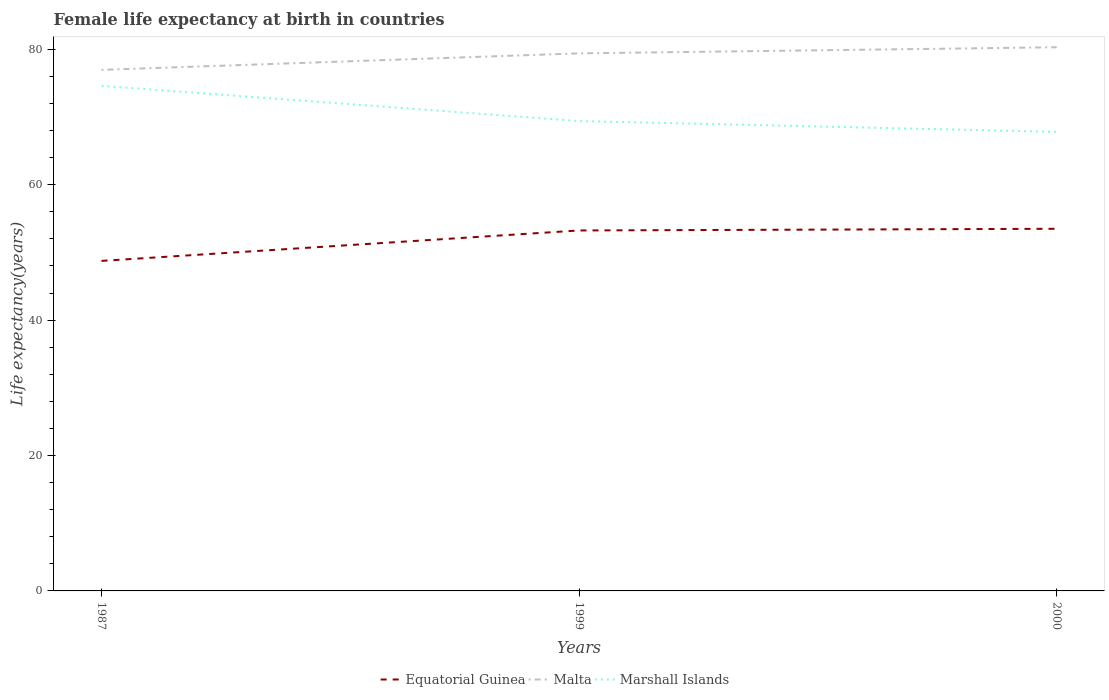Does the line corresponding to Malta intersect with the line corresponding to Marshall Islands?
Give a very brief answer. No. Is the number of lines equal to the number of legend labels?
Keep it short and to the point. Yes. Across all years, what is the maximum female life expectancy at birth in Equatorial Guinea?
Your answer should be compact. 48.74. What is the total female life expectancy at birth in Malta in the graph?
Make the answer very short. -0.9. What is the difference between the highest and the second highest female life expectancy at birth in Marshall Islands?
Your response must be concise. 6.8. What is the difference between the highest and the lowest female life expectancy at birth in Equatorial Guinea?
Make the answer very short. 2. How many lines are there?
Your answer should be compact. 3. How many years are there in the graph?
Your response must be concise. 3. Does the graph contain any zero values?
Your answer should be very brief. No. Does the graph contain grids?
Keep it short and to the point. No. Where does the legend appear in the graph?
Your answer should be compact. Bottom center. How are the legend labels stacked?
Offer a very short reply. Horizontal. What is the title of the graph?
Provide a short and direct response. Female life expectancy at birth in countries. What is the label or title of the Y-axis?
Make the answer very short. Life expectancy(years). What is the Life expectancy(years) in Equatorial Guinea in 1987?
Your answer should be compact. 48.74. What is the Life expectancy(years) in Malta in 1987?
Your answer should be very brief. 76.96. What is the Life expectancy(years) of Marshall Islands in 1987?
Offer a very short reply. 74.6. What is the Life expectancy(years) of Equatorial Guinea in 1999?
Ensure brevity in your answer.  53.24. What is the Life expectancy(years) of Malta in 1999?
Give a very brief answer. 79.4. What is the Life expectancy(years) in Marshall Islands in 1999?
Your answer should be compact. 69.4. What is the Life expectancy(years) in Equatorial Guinea in 2000?
Offer a very short reply. 53.49. What is the Life expectancy(years) of Malta in 2000?
Keep it short and to the point. 80.3. What is the Life expectancy(years) of Marshall Islands in 2000?
Provide a short and direct response. 67.8. Across all years, what is the maximum Life expectancy(years) of Equatorial Guinea?
Offer a terse response. 53.49. Across all years, what is the maximum Life expectancy(years) of Malta?
Your response must be concise. 80.3. Across all years, what is the maximum Life expectancy(years) of Marshall Islands?
Ensure brevity in your answer.  74.6. Across all years, what is the minimum Life expectancy(years) of Equatorial Guinea?
Your response must be concise. 48.74. Across all years, what is the minimum Life expectancy(years) of Malta?
Provide a succinct answer. 76.96. Across all years, what is the minimum Life expectancy(years) in Marshall Islands?
Keep it short and to the point. 67.8. What is the total Life expectancy(years) in Equatorial Guinea in the graph?
Make the answer very short. 155.47. What is the total Life expectancy(years) of Malta in the graph?
Make the answer very short. 236.66. What is the total Life expectancy(years) in Marshall Islands in the graph?
Offer a very short reply. 211.8. What is the difference between the Life expectancy(years) in Equatorial Guinea in 1987 and that in 1999?
Give a very brief answer. -4.5. What is the difference between the Life expectancy(years) in Malta in 1987 and that in 1999?
Your answer should be very brief. -2.44. What is the difference between the Life expectancy(years) in Marshall Islands in 1987 and that in 1999?
Provide a short and direct response. 5.2. What is the difference between the Life expectancy(years) of Equatorial Guinea in 1987 and that in 2000?
Your answer should be compact. -4.74. What is the difference between the Life expectancy(years) of Malta in 1987 and that in 2000?
Offer a terse response. -3.34. What is the difference between the Life expectancy(years) of Equatorial Guinea in 1999 and that in 2000?
Provide a succinct answer. -0.25. What is the difference between the Life expectancy(years) in Marshall Islands in 1999 and that in 2000?
Make the answer very short. 1.6. What is the difference between the Life expectancy(years) of Equatorial Guinea in 1987 and the Life expectancy(years) of Malta in 1999?
Offer a terse response. -30.66. What is the difference between the Life expectancy(years) of Equatorial Guinea in 1987 and the Life expectancy(years) of Marshall Islands in 1999?
Ensure brevity in your answer.  -20.66. What is the difference between the Life expectancy(years) in Malta in 1987 and the Life expectancy(years) in Marshall Islands in 1999?
Keep it short and to the point. 7.56. What is the difference between the Life expectancy(years) of Equatorial Guinea in 1987 and the Life expectancy(years) of Malta in 2000?
Keep it short and to the point. -31.55. What is the difference between the Life expectancy(years) in Equatorial Guinea in 1987 and the Life expectancy(years) in Marshall Islands in 2000?
Keep it short and to the point. -19.05. What is the difference between the Life expectancy(years) in Malta in 1987 and the Life expectancy(years) in Marshall Islands in 2000?
Ensure brevity in your answer.  9.16. What is the difference between the Life expectancy(years) of Equatorial Guinea in 1999 and the Life expectancy(years) of Malta in 2000?
Offer a terse response. -27.06. What is the difference between the Life expectancy(years) of Equatorial Guinea in 1999 and the Life expectancy(years) of Marshall Islands in 2000?
Your answer should be very brief. -14.56. What is the average Life expectancy(years) in Equatorial Guinea per year?
Your answer should be very brief. 51.83. What is the average Life expectancy(years) of Malta per year?
Provide a short and direct response. 78.89. What is the average Life expectancy(years) of Marshall Islands per year?
Provide a short and direct response. 70.6. In the year 1987, what is the difference between the Life expectancy(years) in Equatorial Guinea and Life expectancy(years) in Malta?
Offer a very short reply. -28.22. In the year 1987, what is the difference between the Life expectancy(years) of Equatorial Guinea and Life expectancy(years) of Marshall Islands?
Keep it short and to the point. -25.86. In the year 1987, what is the difference between the Life expectancy(years) of Malta and Life expectancy(years) of Marshall Islands?
Provide a short and direct response. 2.36. In the year 1999, what is the difference between the Life expectancy(years) in Equatorial Guinea and Life expectancy(years) in Malta?
Offer a terse response. -26.16. In the year 1999, what is the difference between the Life expectancy(years) in Equatorial Guinea and Life expectancy(years) in Marshall Islands?
Your response must be concise. -16.16. In the year 1999, what is the difference between the Life expectancy(years) of Malta and Life expectancy(years) of Marshall Islands?
Provide a succinct answer. 10. In the year 2000, what is the difference between the Life expectancy(years) in Equatorial Guinea and Life expectancy(years) in Malta?
Your response must be concise. -26.81. In the year 2000, what is the difference between the Life expectancy(years) of Equatorial Guinea and Life expectancy(years) of Marshall Islands?
Ensure brevity in your answer.  -14.31. What is the ratio of the Life expectancy(years) of Equatorial Guinea in 1987 to that in 1999?
Provide a succinct answer. 0.92. What is the ratio of the Life expectancy(years) of Malta in 1987 to that in 1999?
Your response must be concise. 0.97. What is the ratio of the Life expectancy(years) of Marshall Islands in 1987 to that in 1999?
Give a very brief answer. 1.07. What is the ratio of the Life expectancy(years) in Equatorial Guinea in 1987 to that in 2000?
Provide a succinct answer. 0.91. What is the ratio of the Life expectancy(years) of Malta in 1987 to that in 2000?
Give a very brief answer. 0.96. What is the ratio of the Life expectancy(years) of Marshall Islands in 1987 to that in 2000?
Your answer should be compact. 1.1. What is the ratio of the Life expectancy(years) in Equatorial Guinea in 1999 to that in 2000?
Offer a terse response. 1. What is the ratio of the Life expectancy(years) in Marshall Islands in 1999 to that in 2000?
Ensure brevity in your answer.  1.02. What is the difference between the highest and the second highest Life expectancy(years) of Equatorial Guinea?
Give a very brief answer. 0.25. What is the difference between the highest and the second highest Life expectancy(years) in Marshall Islands?
Your answer should be very brief. 5.2. What is the difference between the highest and the lowest Life expectancy(years) of Equatorial Guinea?
Your response must be concise. 4.74. What is the difference between the highest and the lowest Life expectancy(years) in Malta?
Keep it short and to the point. 3.34. What is the difference between the highest and the lowest Life expectancy(years) in Marshall Islands?
Provide a short and direct response. 6.8. 